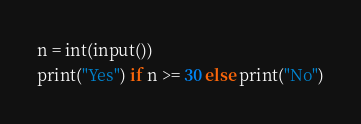Convert code to text. <code><loc_0><loc_0><loc_500><loc_500><_Python_>n = int(input())
print("Yes") if n >= 30 else print("No")</code> 